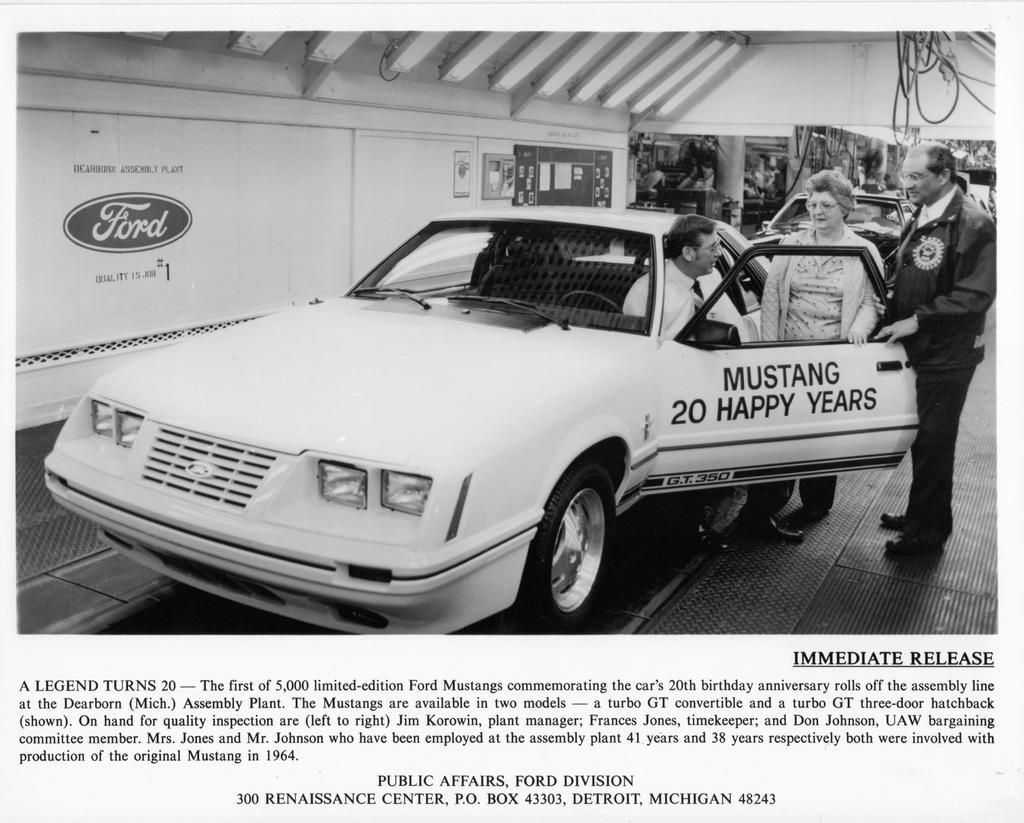How many people are present in the image? There are three persons in the image. What are the positions of the people in the image? One person is sitting inside the car, and two persons are standing behind the car. Can you describe the setting of the image? The image appears to be related to an article, but the specific context is not clear from the facts provided. What type of rifle is the person holding in the image? There is no rifle present in the image; it only features three persons, one sitting in a car and two standing behind it. 